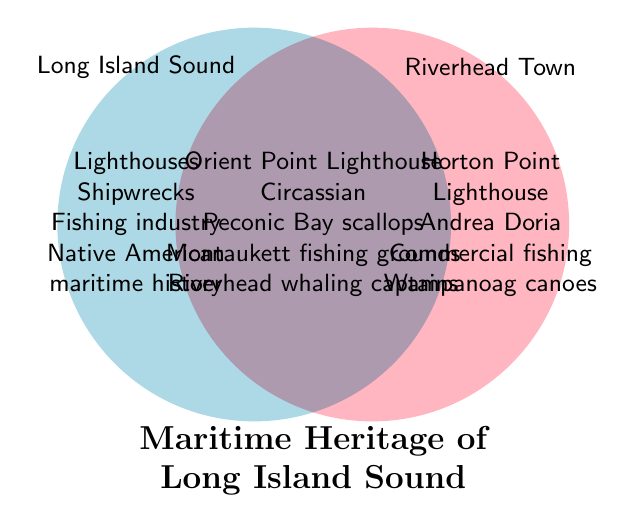Which lighthouse is specific to Riverhead Town? The figure shows Horton Point Lighthouse under the Riverhead Town circle.
Answer: Horton Point Lighthouse Which shipwreck is common to both Riverhead Town and Long Island Sound? In the intersection part of the diagram (both circles), the figure shows Circassian.
Answer: Circassian What is unique to the fishing industry in Long Island Sound compared to Riverhead Town? Checking the elements specific to Long Island Sound, the figure lists commercial fishing under Long Island Sound only.
Answer: Commercial fishing Name one maritime museum specific to Riverhead Town. The figure shows Long Island Maritime Museum in the section specific to Riverhead Town.
Answer: Long Island Maritime Museum Identify a historic port listed in the figure but not in the intersection. New London is listed under Long Island Sound, and not in the intersection part.
Answer: New London Which oyster cultivation location is unique to Riverhead Town? In the section specific to Riverhead Town, the figure lists Peconic Bay oysters.
Answer: Peconic Bay oysters Name any whaling heritage site relevant to Riverhead Town. The figure shows Riverhead whaling captains under the intersection, implying relevance to Riverhead Town.
Answer: Riverhead whaling captains What feature does the figure place in both Long Island Sound and Riverhead Town areas? The intersection part of the figure lists several features indicating they are present in both areas, such as Orient Point Lighthouse.
Answer: Orient Point Lighthouse Which recreational boating area is found in Riverhead Town but not in Long Island Sound as per the figure? The figure lists Peconic River under the Riverhead Town section only.
Answer: Peconic River Name a coastal fortification listed under Long Island Sound. For Long Island Sound, the figure shows Fort Trumbull.
Answer: Fort Trumbull 